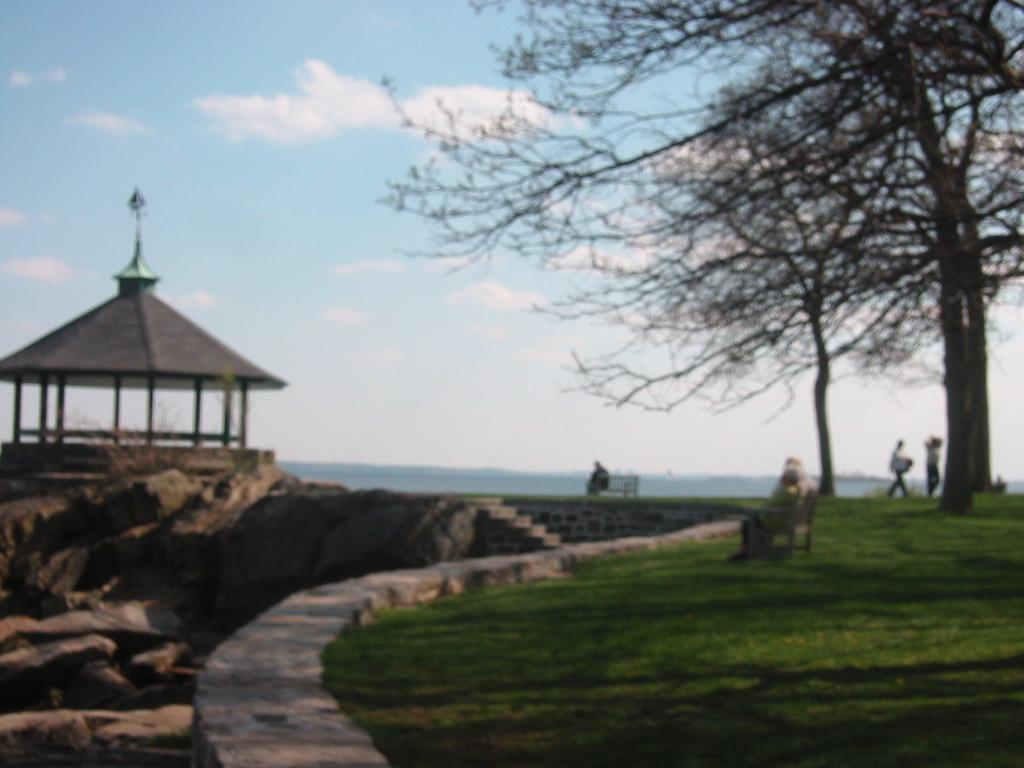What type of vegetation can be seen in the image? There are dry trees in the image. Who or what else is present in the image? There are people and a shed in the image. What material is the shed made of? The shed is made of stones, which are also present in the image. Are there any architectural features in the image? Yes, there are stairs in the image. What is the natural environment like in the image? Grass is visible in the image. What are the people in the image doing? People are sitting on benches in the image. What is the color of the sky in the image? The sky is white and blue in color. What is the price of the throne in the image? There is no throne present in the image. What fact can be learned from the image? The image itself does not convey any specific facts, as it is a visual representation. 